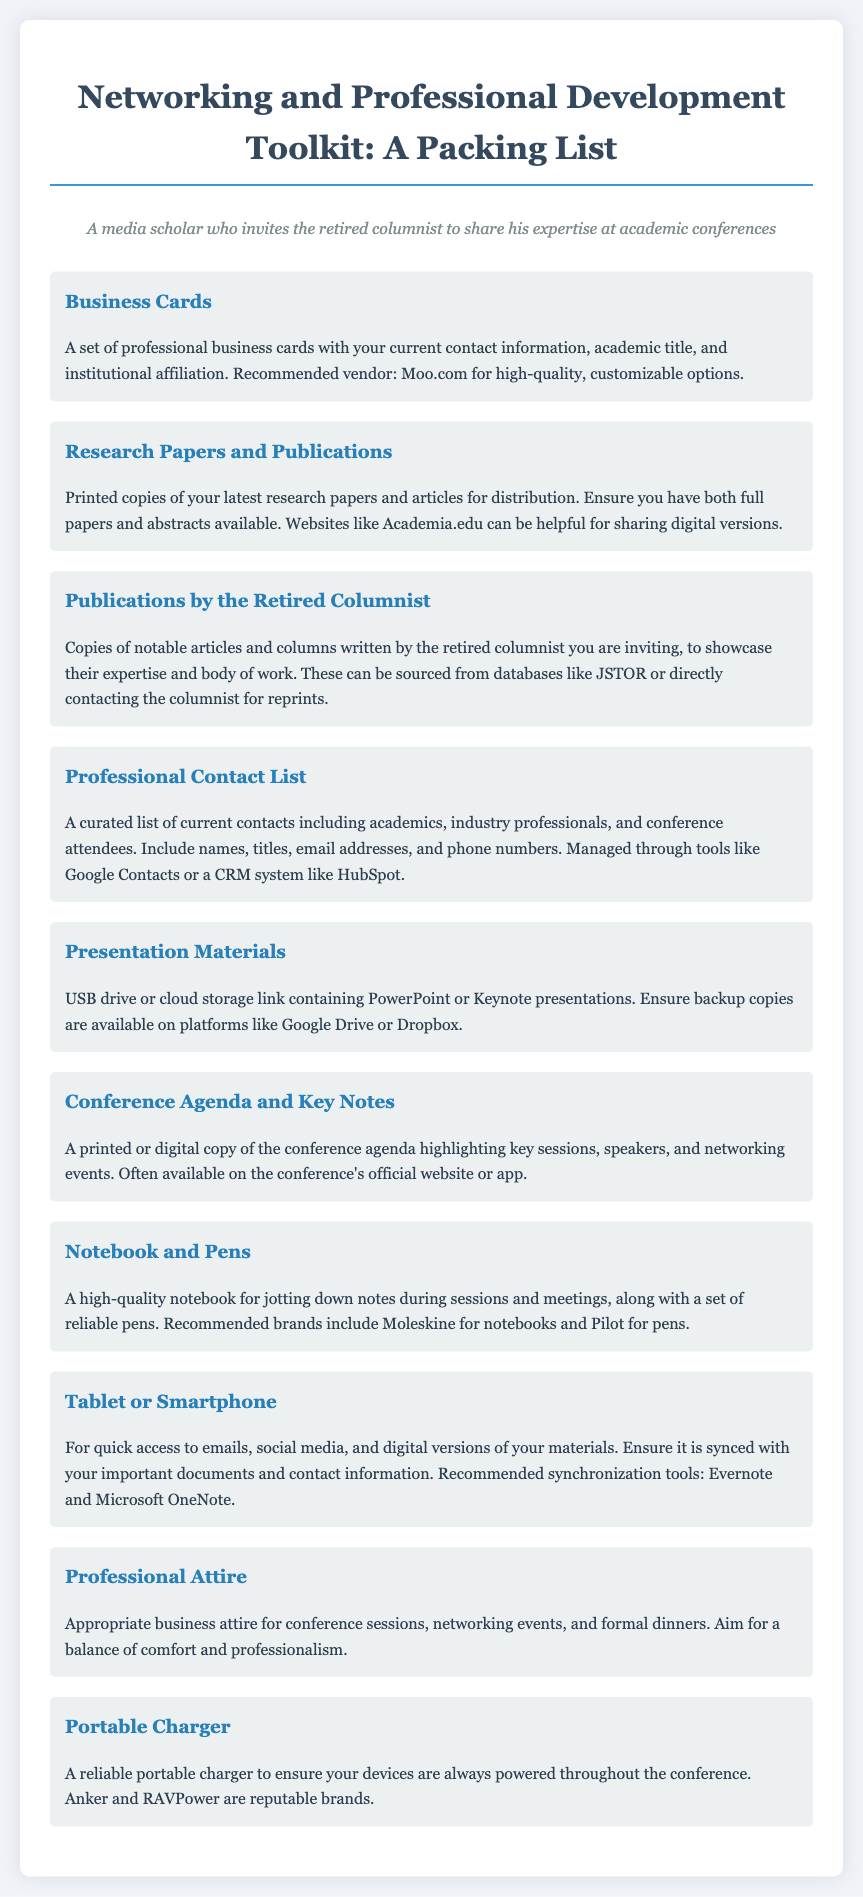What is the recommended vendor for business cards? The document mentions Moo.com as the recommended vendor for high-quality, customizable business cards.
Answer: Moo.com What type of materials should you bring to showcase the retired columnist's expertise? The document specifies that copies of notable articles and columns written by the retired columnist should be brought.
Answer: Articles and columns Which tool is suggested for managing a professional contact list? The document suggests using tools like Google Contacts or a CRM system like HubSpot to manage contacts.
Answer: Google Contacts What is a necessary item to ensure device power throughout the conference? The document lists a reliable portable charger as a necessary item for device power.
Answer: Portable charger What kind of attire is recommended for professional events? The document advises wearing appropriate business attire for conference sessions and networking events.
Answer: Business attire How many items are included in the packing list? The document outlines a total of ten different items in the packing list for networking and professional development.
Answer: Ten items What should you use for jotting down notes during sessions? A high-quality notebook is recommended for jotting down notes during sessions and meetings.
Answer: Notebook Which storage options are suggested for presentation materials? The document recommends using a USB drive or cloud storage link for presentation materials.
Answer: USB drive or cloud storage What type of documents should you prepare for distribution at the conference? Printed copies of your latest research papers and articles are suggested for distribution.
Answer: Research papers and articles What are two recommended brands for notebooks and pens? Moleskine for notebooks and Pilot for pens are the recommended brands mentioned in the document.
Answer: Moleskine and Pilot 